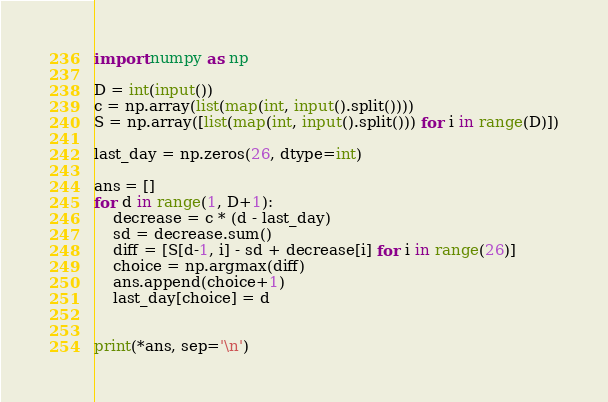Convert code to text. <code><loc_0><loc_0><loc_500><loc_500><_Python_>import numpy as np

D = int(input())
c = np.array(list(map(int, input().split())))
S = np.array([list(map(int, input().split())) for i in range(D)])

last_day = np.zeros(26, dtype=int)

ans = []
for d in range(1, D+1):
    decrease = c * (d - last_day)
    sd = decrease.sum()
    diff = [S[d-1, i] - sd + decrease[i] for i in range(26)]
    choice = np.argmax(diff)
    ans.append(choice+1)
    last_day[choice] = d


print(*ans, sep='\n')</code> 